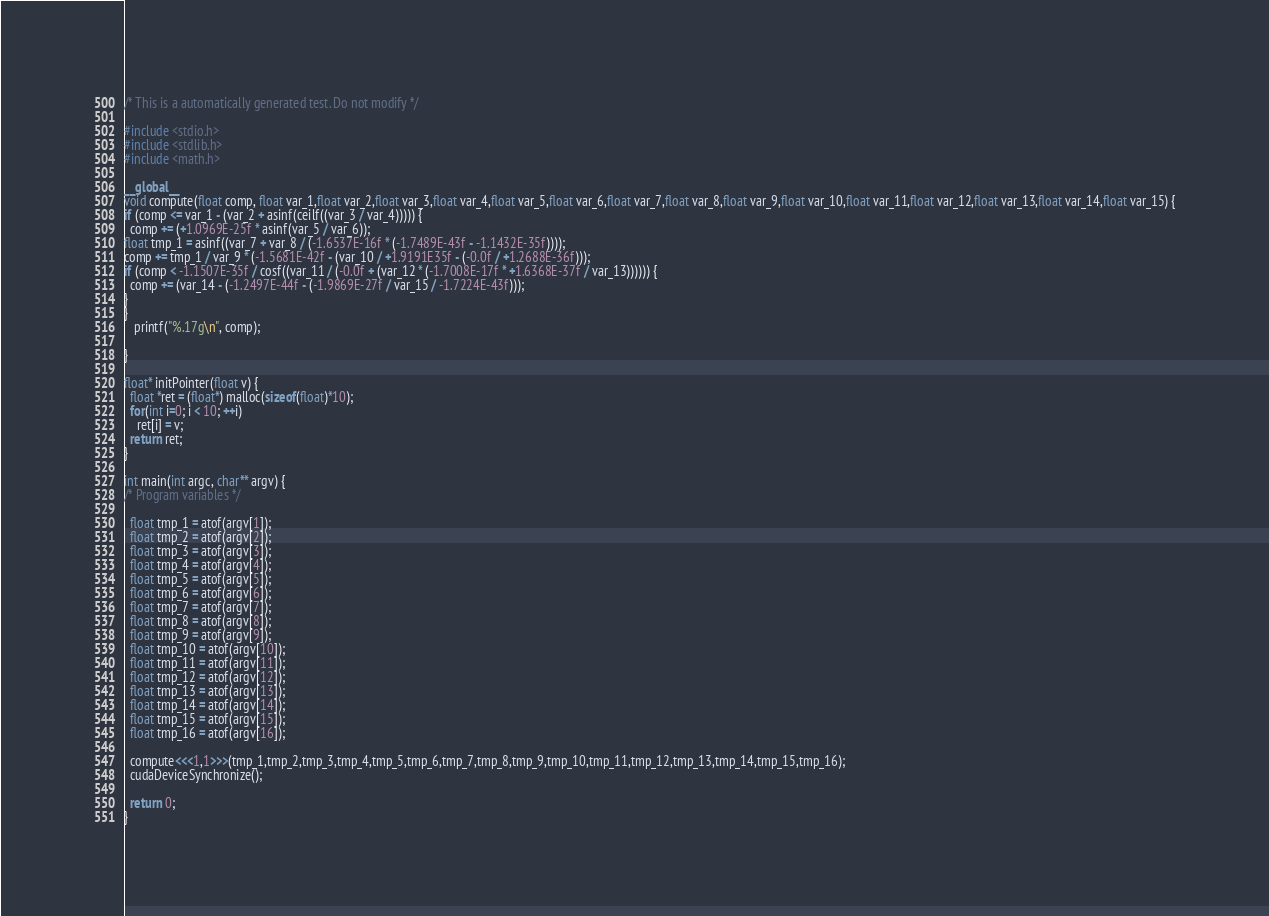Convert code to text. <code><loc_0><loc_0><loc_500><loc_500><_Cuda_>
/* This is a automatically generated test. Do not modify */

#include <stdio.h>
#include <stdlib.h>
#include <math.h>

__global__
void compute(float comp, float var_1,float var_2,float var_3,float var_4,float var_5,float var_6,float var_7,float var_8,float var_9,float var_10,float var_11,float var_12,float var_13,float var_14,float var_15) {
if (comp <= var_1 - (var_2 + asinf(ceilf((var_3 / var_4))))) {
  comp += (+1.0969E-25f * asinf(var_5 / var_6));
float tmp_1 = asinf((var_7 + var_8 / (-1.6537E-16f * (-1.7489E-43f - -1.1432E-35f))));
comp += tmp_1 / var_9 * (-1.5681E-42f - (var_10 / +1.9191E35f - (-0.0f / +1.2688E-36f)));
if (comp < -1.1507E-35f / cosf((var_11 / (-0.0f + (var_12 * (-1.7008E-17f * +1.6368E-37f / var_13)))))) {
  comp += (var_14 - (-1.2497E-44f - (-1.9869E-27f / var_15 / -1.7224E-43f)));
}
}
   printf("%.17g\n", comp);

}

float* initPointer(float v) {
  float *ret = (float*) malloc(sizeof(float)*10);
  for(int i=0; i < 10; ++i)
    ret[i] = v;
  return ret;
}

int main(int argc, char** argv) {
/* Program variables */

  float tmp_1 = atof(argv[1]);
  float tmp_2 = atof(argv[2]);
  float tmp_3 = atof(argv[3]);
  float tmp_4 = atof(argv[4]);
  float tmp_5 = atof(argv[5]);
  float tmp_6 = atof(argv[6]);
  float tmp_7 = atof(argv[7]);
  float tmp_8 = atof(argv[8]);
  float tmp_9 = atof(argv[9]);
  float tmp_10 = atof(argv[10]);
  float tmp_11 = atof(argv[11]);
  float tmp_12 = atof(argv[12]);
  float tmp_13 = atof(argv[13]);
  float tmp_14 = atof(argv[14]);
  float tmp_15 = atof(argv[15]);
  float tmp_16 = atof(argv[16]);

  compute<<<1,1>>>(tmp_1,tmp_2,tmp_3,tmp_4,tmp_5,tmp_6,tmp_7,tmp_8,tmp_9,tmp_10,tmp_11,tmp_12,tmp_13,tmp_14,tmp_15,tmp_16);
  cudaDeviceSynchronize();

  return 0;
}
</code> 